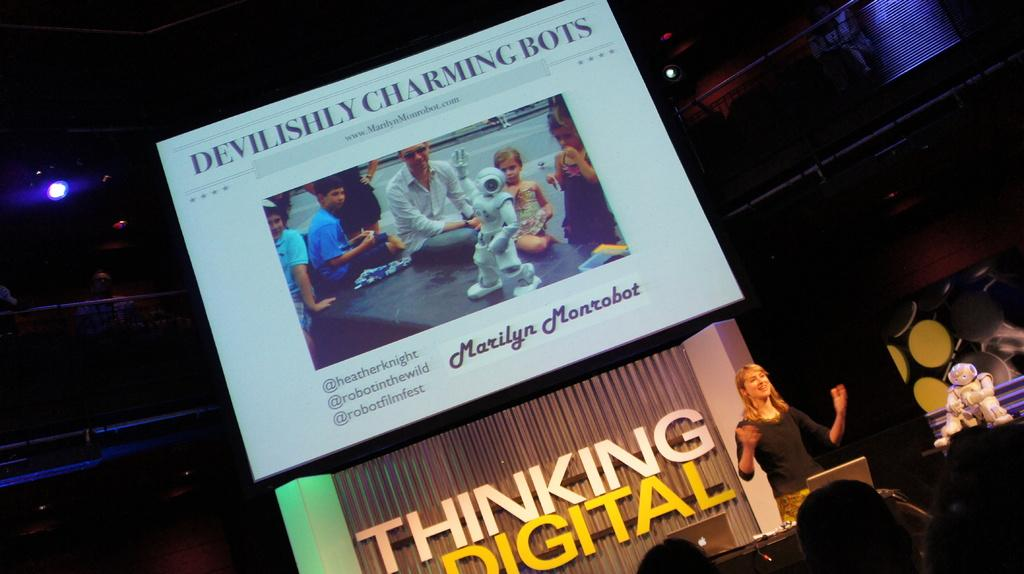<image>
Offer a succinct explanation of the picture presented. A large projector screen is showing a slide that says Devilishly Charming Bots and shows people gathered around a small robot. 